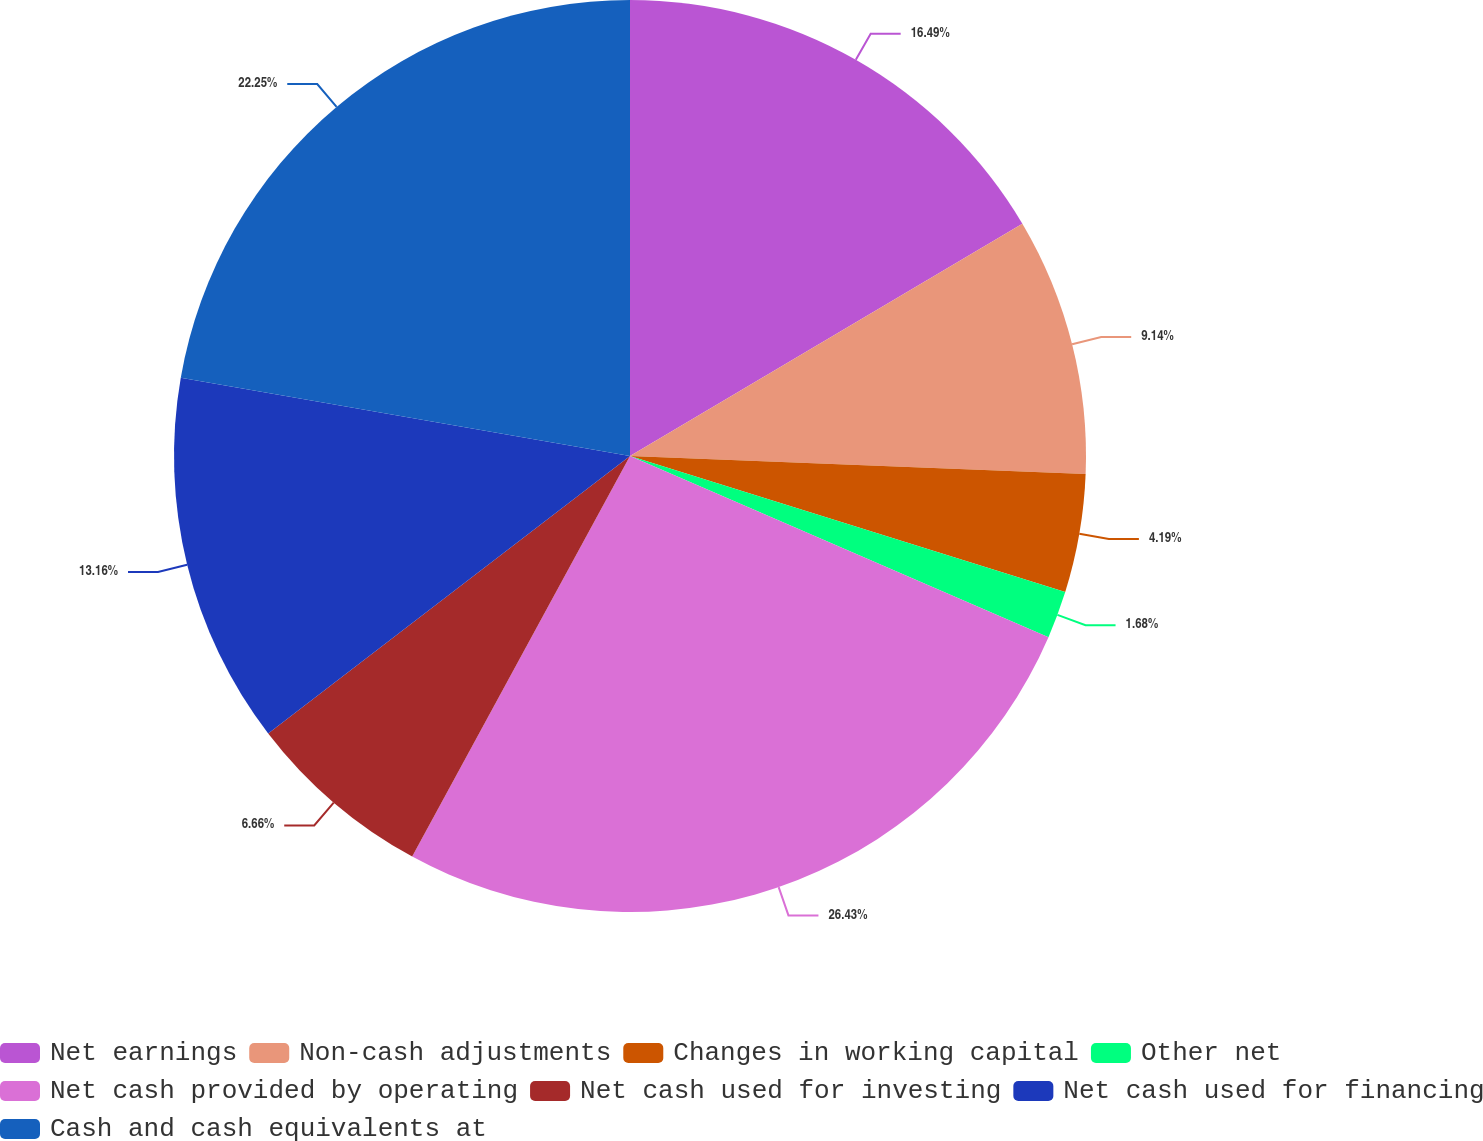<chart> <loc_0><loc_0><loc_500><loc_500><pie_chart><fcel>Net earnings<fcel>Non-cash adjustments<fcel>Changes in working capital<fcel>Other net<fcel>Net cash provided by operating<fcel>Net cash used for investing<fcel>Net cash used for financing<fcel>Cash and cash equivalents at<nl><fcel>16.49%<fcel>9.14%<fcel>4.19%<fcel>1.68%<fcel>26.42%<fcel>6.66%<fcel>13.16%<fcel>22.25%<nl></chart> 